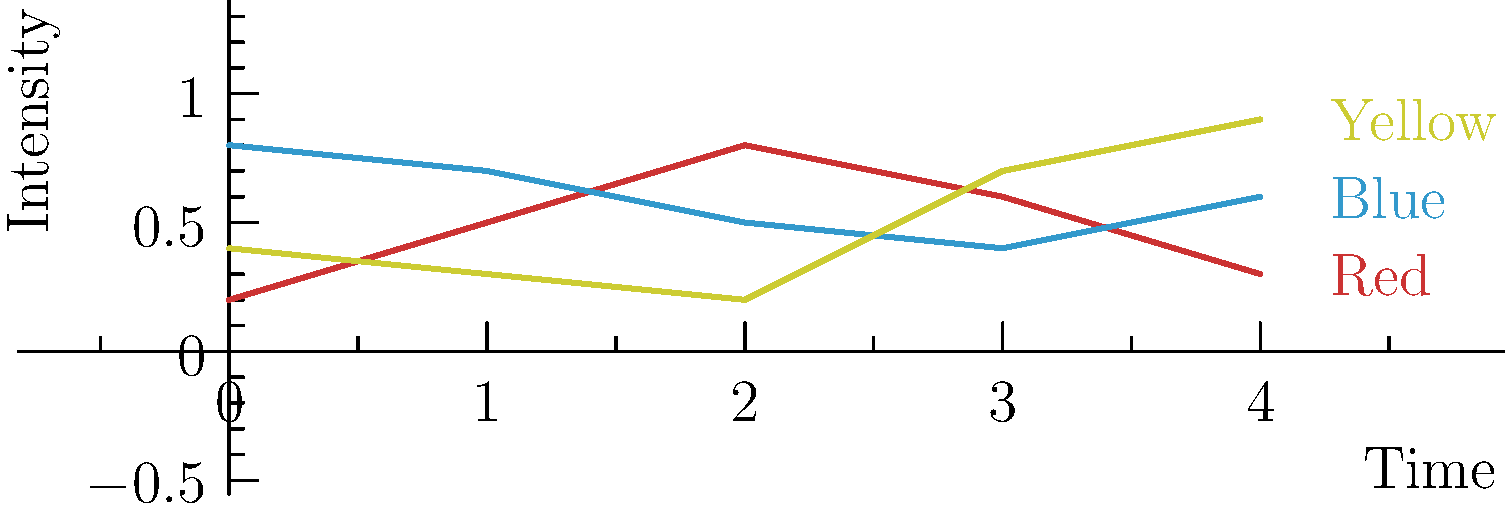In this color palette chart representing mood transitions in a music video, which color shows the most dramatic increase in intensity towards the end of the video, potentially signifying a climactic moment? To determine which color shows the most dramatic increase in intensity towards the end of the video, we need to analyze the graph for each color:

1. Red (top line at the start):
   - Starts high, increases slightly, then decreases towards the end.
   - No significant increase at the end.

2. Blue (middle line at the start):
   - Starts moderately high, decreases gradually, then shows a slight increase at the end.
   - The increase at the end is minimal.

3. Yellow (bottom line at the start):
   - Starts low, decreases slightly, then shows a sharp increase towards the end.
   - The increase is the most dramatic among all three colors.

The yellow line shows the most significant upward trajectory in the final segment of the graph, indicating a sudden and dramatic increase in intensity. This could represent a climactic moment in the music video, where the mood shifts dramatically, perhaps coinciding with a key moment in the song or narrative.

As an aspiring music video director, recognizing these color transitions is crucial for creating visually compelling and emotionally resonant videos. The dramatic rise of the yellow color could be used to emphasize a pivotal moment, such as a chorus climax or a narrative turning point, aligning with techniques often employed by directors like Frank Borin.
Answer: Yellow 